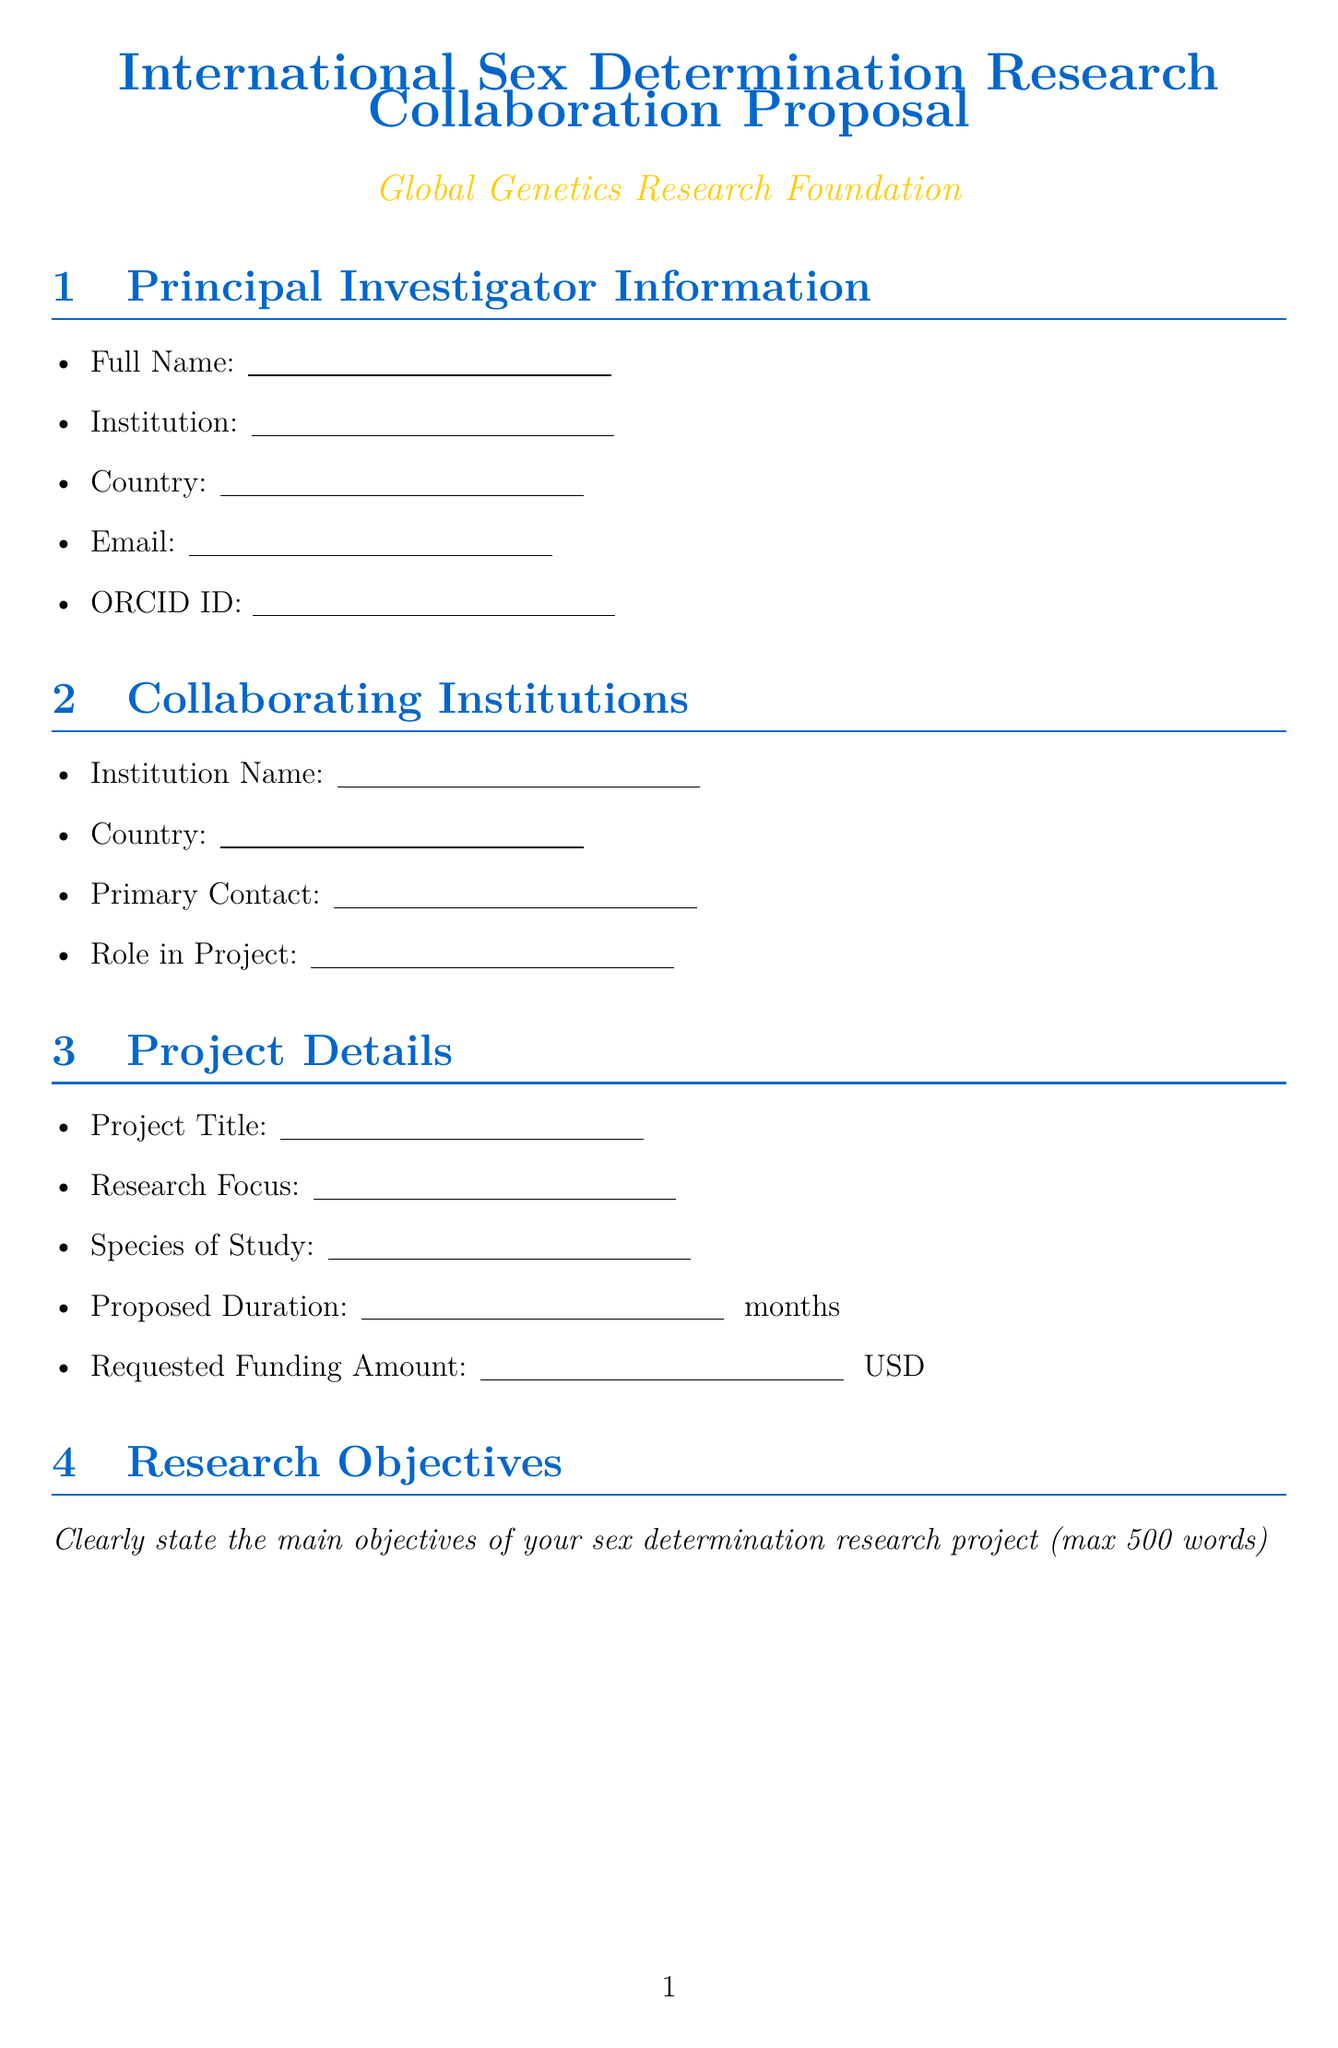What is the title of the proposal form? The title of the proposal form is the section heading provided at the top of the document.
Answer: International Sex Determination Research Collaboration Proposal Who is the funding agency? The funding agency is mentioned in the document, which is noted in the header.
Answer: Global Genetics Research Foundation What is the maximum word limit for the research objectives? The maximum word limit is specified in the research objectives section.
Answer: 500 words How many categories are listed in the budget breakdown? The number of categories is determined by counting the bullet points in that section.
Answer: 5 What is the submission deadline? The submission deadline is clearly stated in the submission instructions section.
Answer: September 30, 2023 What type of documents are required for letters of support? The document type required for letters of support is indicated in that specific section.
Answer: PDF format Which section contains information on data sharing? The section where data sharing is discussed is explicitly labeled in the document.
Answer: Data Sharing and Management What are the primary fields required under collaborating institutions? The fields can be identified by reviewing the items listed under that section.
Answer: Institution Name, Country, Primary Contact, Role in Project What is the purpose of the collaboration plan section? The purpose is outlined within the description associated with that section in the document.
Answer: Enhance the research outcomes 